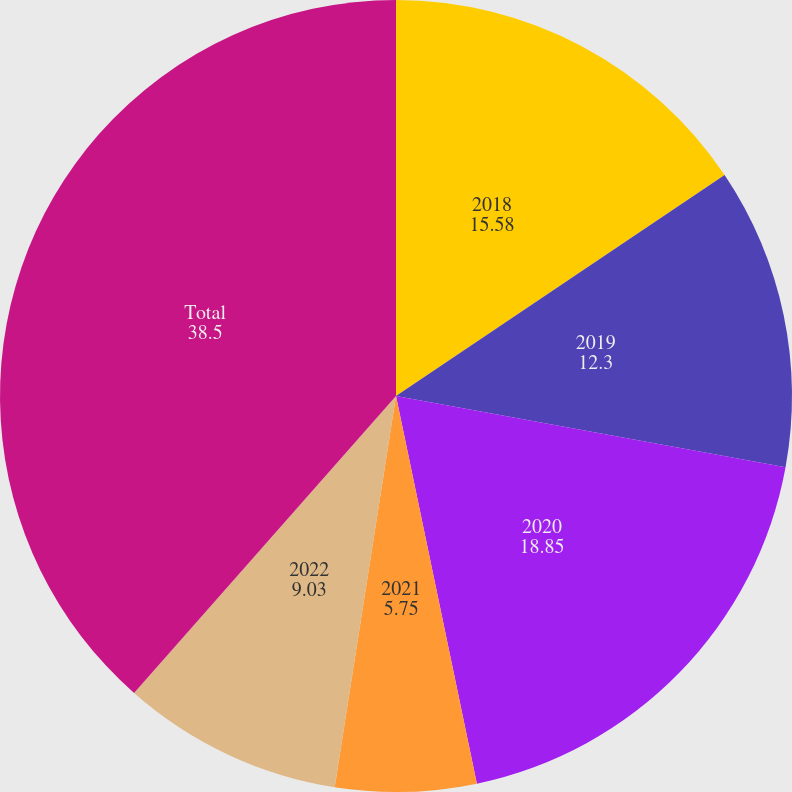Convert chart. <chart><loc_0><loc_0><loc_500><loc_500><pie_chart><fcel>2018<fcel>2019<fcel>2020<fcel>2021<fcel>2022<fcel>Total<nl><fcel>15.58%<fcel>12.3%<fcel>18.85%<fcel>5.75%<fcel>9.03%<fcel>38.5%<nl></chart> 